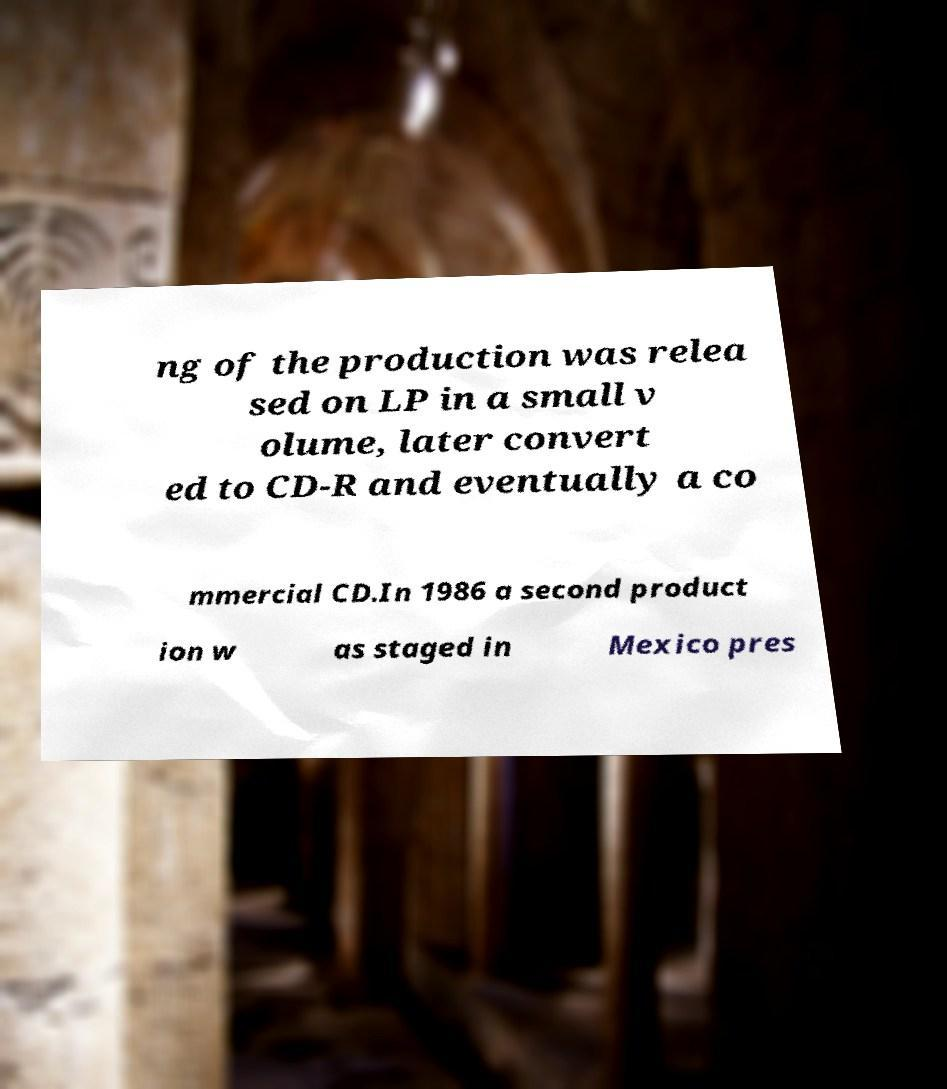I need the written content from this picture converted into text. Can you do that? ng of the production was relea sed on LP in a small v olume, later convert ed to CD-R and eventually a co mmercial CD.In 1986 a second product ion w as staged in Mexico pres 